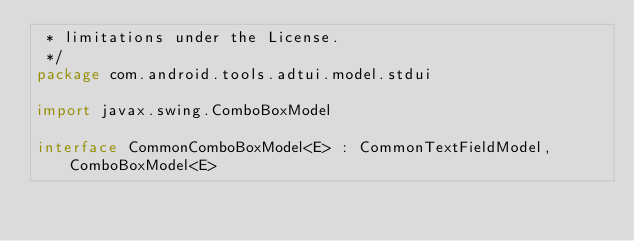Convert code to text. <code><loc_0><loc_0><loc_500><loc_500><_Kotlin_> * limitations under the License.
 */
package com.android.tools.adtui.model.stdui

import javax.swing.ComboBoxModel

interface CommonComboBoxModel<E> : CommonTextFieldModel, ComboBoxModel<E>
</code> 